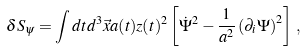Convert formula to latex. <formula><loc_0><loc_0><loc_500><loc_500>\delta S _ { \psi } = \int d t d ^ { 3 } \vec { x } a ( t ) z ( t ) ^ { 2 } \left [ \dot { \Psi } ^ { 2 } - \frac { 1 } { a ^ { 2 } } \left ( \partial _ { i } \Psi \right ) ^ { 2 } \right ] \, ,</formula> 